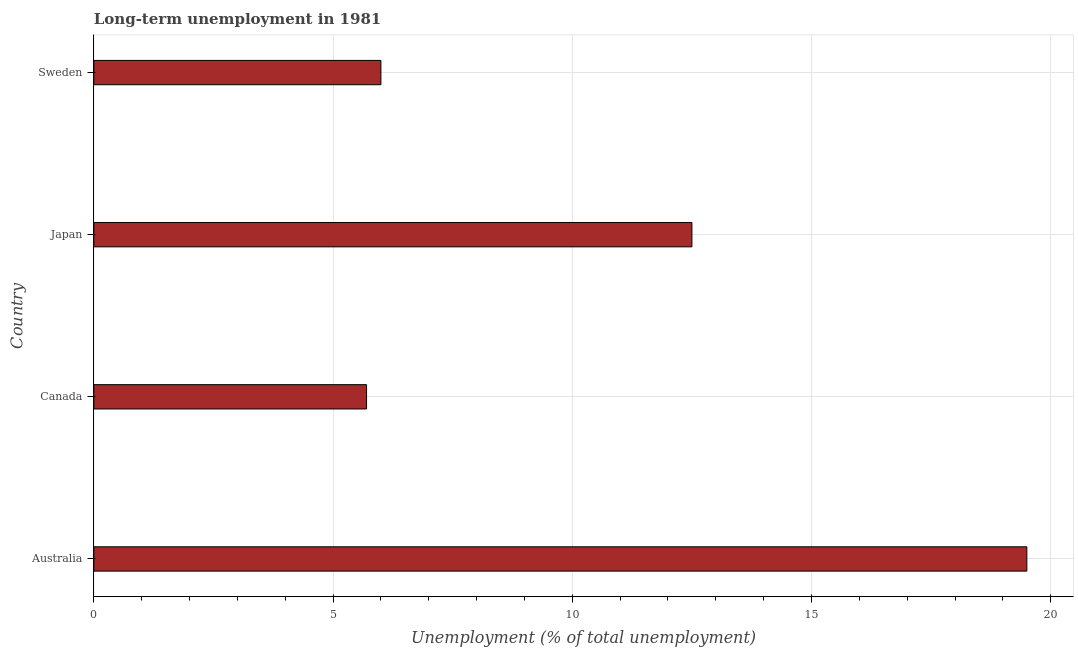Does the graph contain any zero values?
Make the answer very short. No. What is the title of the graph?
Offer a terse response. Long-term unemployment in 1981. What is the label or title of the X-axis?
Your response must be concise. Unemployment (% of total unemployment). What is the label or title of the Y-axis?
Make the answer very short. Country. What is the long-term unemployment in Canada?
Your response must be concise. 5.7. Across all countries, what is the maximum long-term unemployment?
Offer a very short reply. 19.5. Across all countries, what is the minimum long-term unemployment?
Give a very brief answer. 5.7. In which country was the long-term unemployment minimum?
Your answer should be very brief. Canada. What is the sum of the long-term unemployment?
Your answer should be compact. 43.7. What is the average long-term unemployment per country?
Keep it short and to the point. 10.93. What is the median long-term unemployment?
Offer a very short reply. 9.25. In how many countries, is the long-term unemployment greater than 4 %?
Ensure brevity in your answer.  4. What is the ratio of the long-term unemployment in Australia to that in Canada?
Ensure brevity in your answer.  3.42. What is the difference between the highest and the second highest long-term unemployment?
Ensure brevity in your answer.  7. In how many countries, is the long-term unemployment greater than the average long-term unemployment taken over all countries?
Your response must be concise. 2. How many countries are there in the graph?
Your response must be concise. 4. What is the difference between two consecutive major ticks on the X-axis?
Your answer should be compact. 5. Are the values on the major ticks of X-axis written in scientific E-notation?
Your answer should be very brief. No. What is the Unemployment (% of total unemployment) of Canada?
Keep it short and to the point. 5.7. What is the Unemployment (% of total unemployment) of Japan?
Provide a short and direct response. 12.5. What is the Unemployment (% of total unemployment) in Sweden?
Provide a succinct answer. 6. What is the difference between the Unemployment (% of total unemployment) in Australia and Canada?
Provide a short and direct response. 13.8. What is the difference between the Unemployment (% of total unemployment) in Australia and Sweden?
Give a very brief answer. 13.5. What is the difference between the Unemployment (% of total unemployment) in Canada and Japan?
Keep it short and to the point. -6.8. What is the difference between the Unemployment (% of total unemployment) in Japan and Sweden?
Keep it short and to the point. 6.5. What is the ratio of the Unemployment (% of total unemployment) in Australia to that in Canada?
Provide a succinct answer. 3.42. What is the ratio of the Unemployment (% of total unemployment) in Australia to that in Japan?
Your answer should be very brief. 1.56. What is the ratio of the Unemployment (% of total unemployment) in Canada to that in Japan?
Keep it short and to the point. 0.46. What is the ratio of the Unemployment (% of total unemployment) in Japan to that in Sweden?
Your response must be concise. 2.08. 